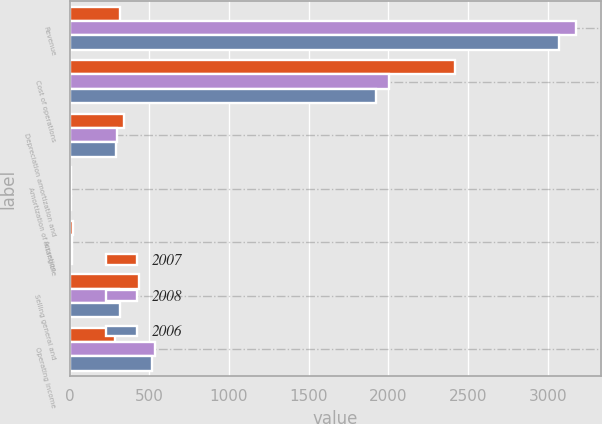Convert chart to OTSL. <chart><loc_0><loc_0><loc_500><loc_500><stacked_bar_chart><ecel><fcel>Revenue<fcel>Cost of operations<fcel>Depreciation amortization and<fcel>Amortization of intangible<fcel>Accretion<fcel>Selling general and<fcel>Operating income<nl><fcel>2007<fcel>314.35<fcel>2416.7<fcel>342.3<fcel>11.8<fcel>23.9<fcel>434.7<fcel>283.2<nl><fcel>2008<fcel>3176.2<fcel>2003.9<fcel>299<fcel>6.5<fcel>17.1<fcel>313.7<fcel>536<nl><fcel>2006<fcel>3070.6<fcel>1924.4<fcel>289<fcel>7<fcel>15.7<fcel>315<fcel>519.5<nl></chart> 